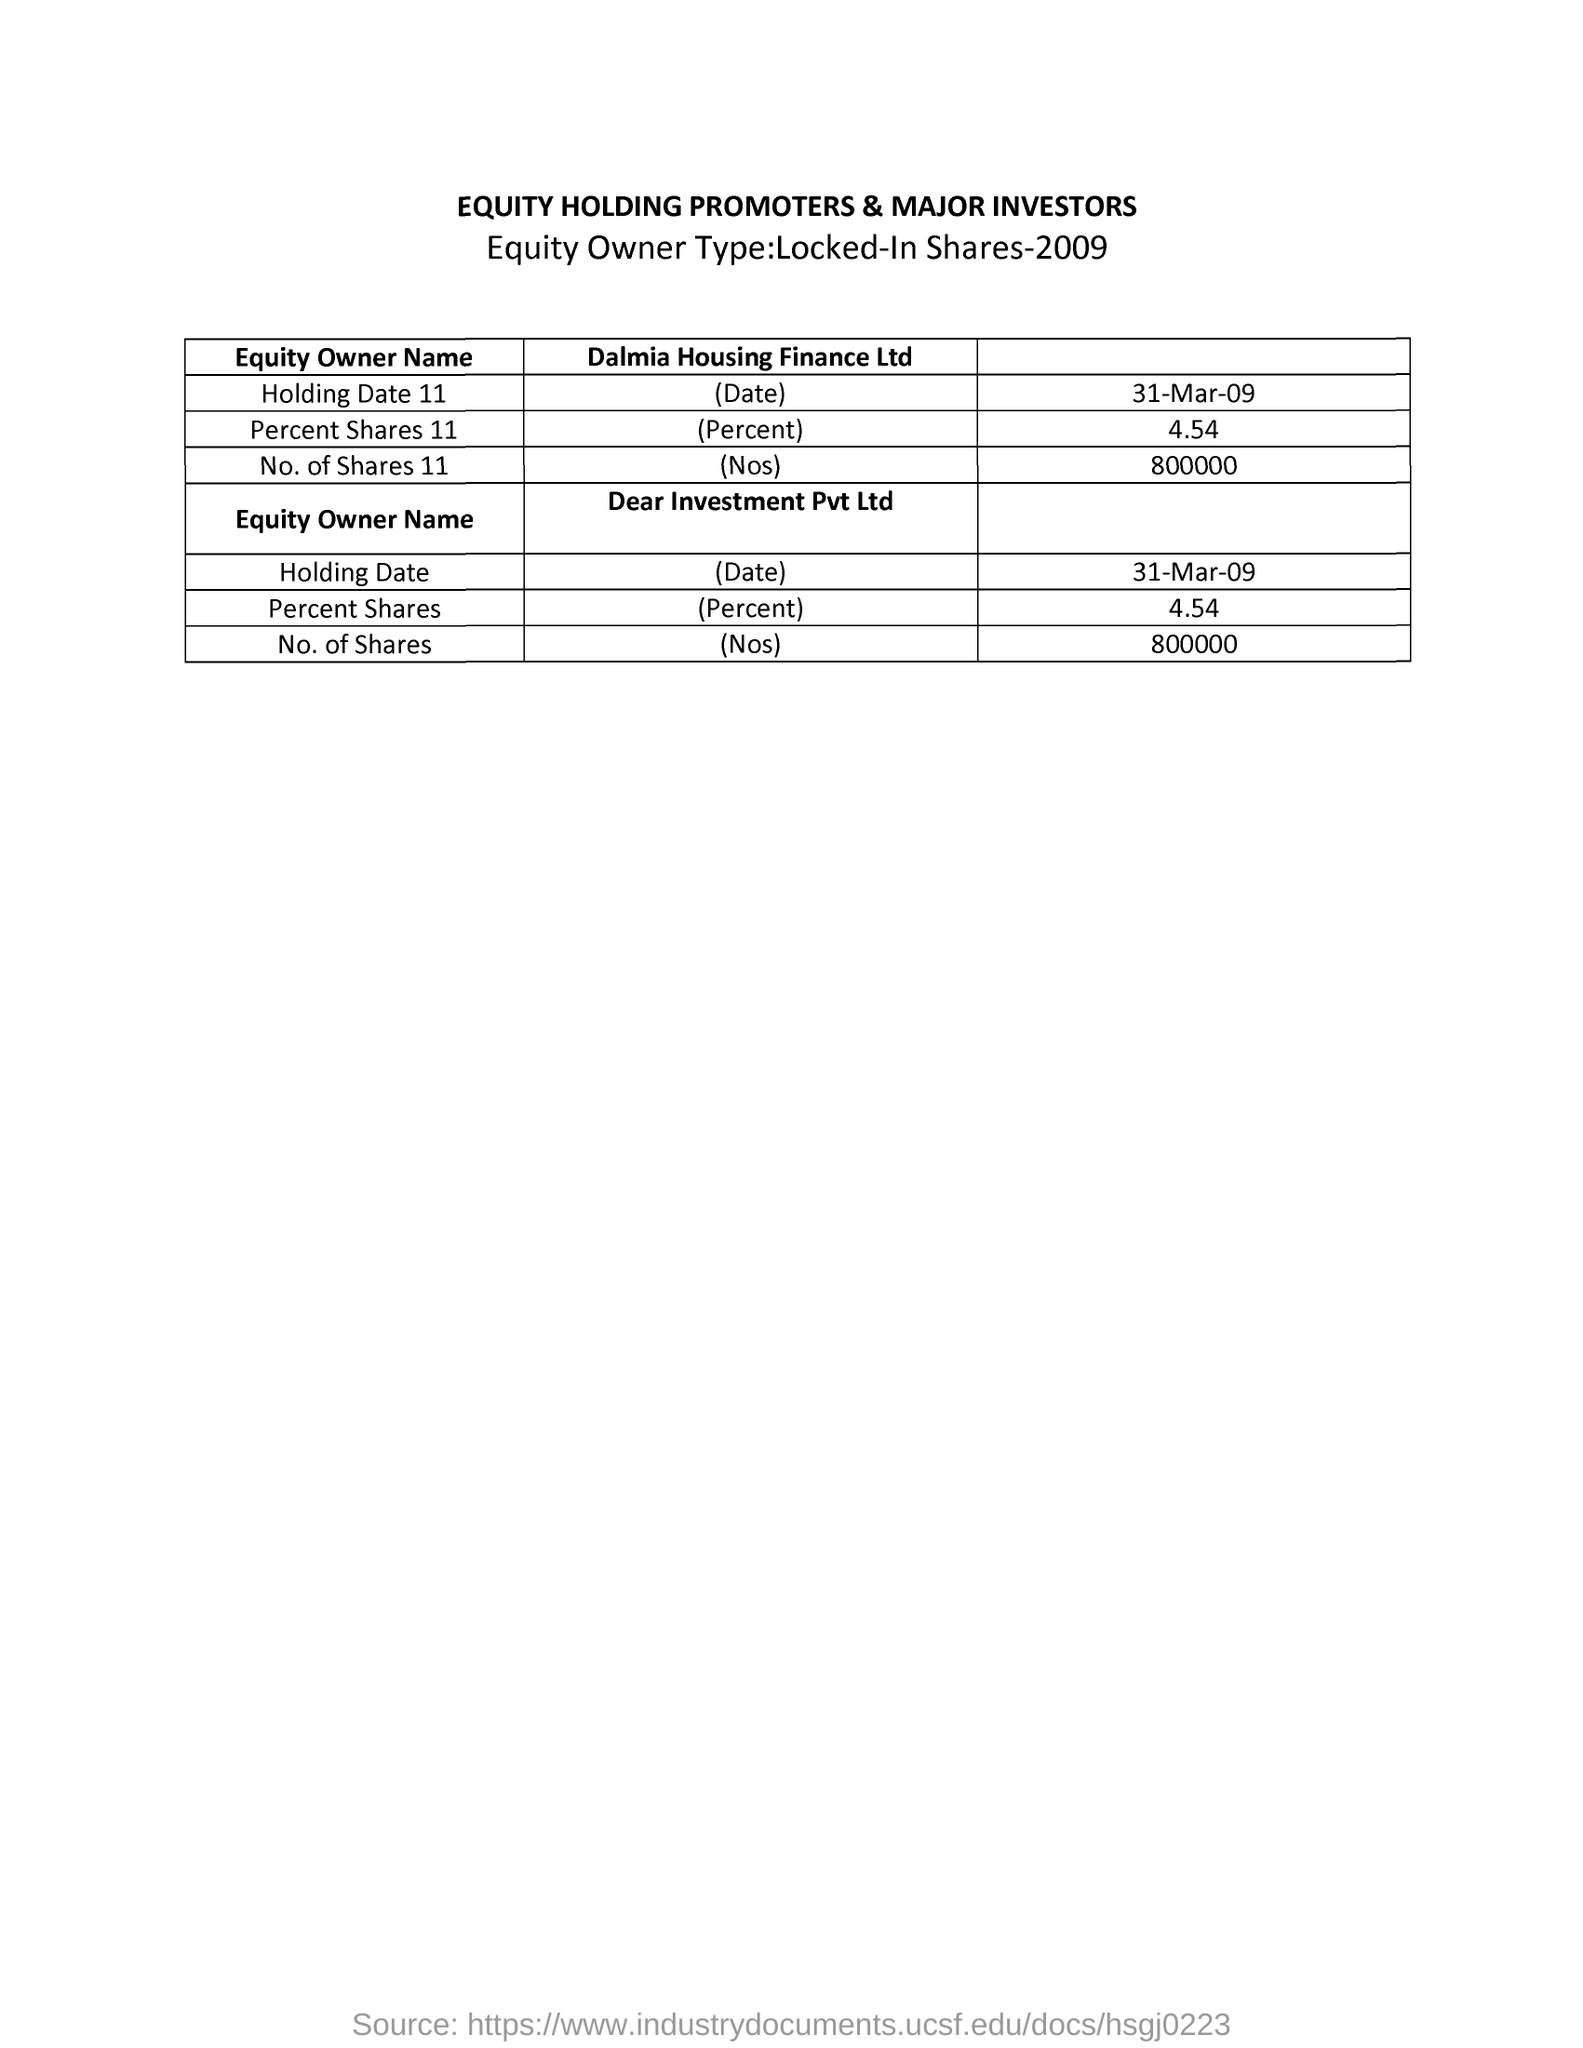What is the table about?
Offer a terse response. Equity holding promoters & major investors. What is the holding date 11 of dalmia housing finance Ltd.?
Your response must be concise. 31-mar-09. What is the Percent shares 11 of Dalmia Housing Finance Ltd.?
Provide a short and direct response. 4.54. What is the No.of shares of Dalmia Housing Finance Ltd.?
Offer a terse response. 800000. What is the holding date of Dear Investment Pvt.Ltd?
Your response must be concise. 31-mar-09. What is the Percent share of Dear Investment Pvt. Ltd?
Your answer should be very brief. 4 54. What is the No. Of shares of Dear Investment Pvt.Ltd?
Your answer should be compact. 800000. 